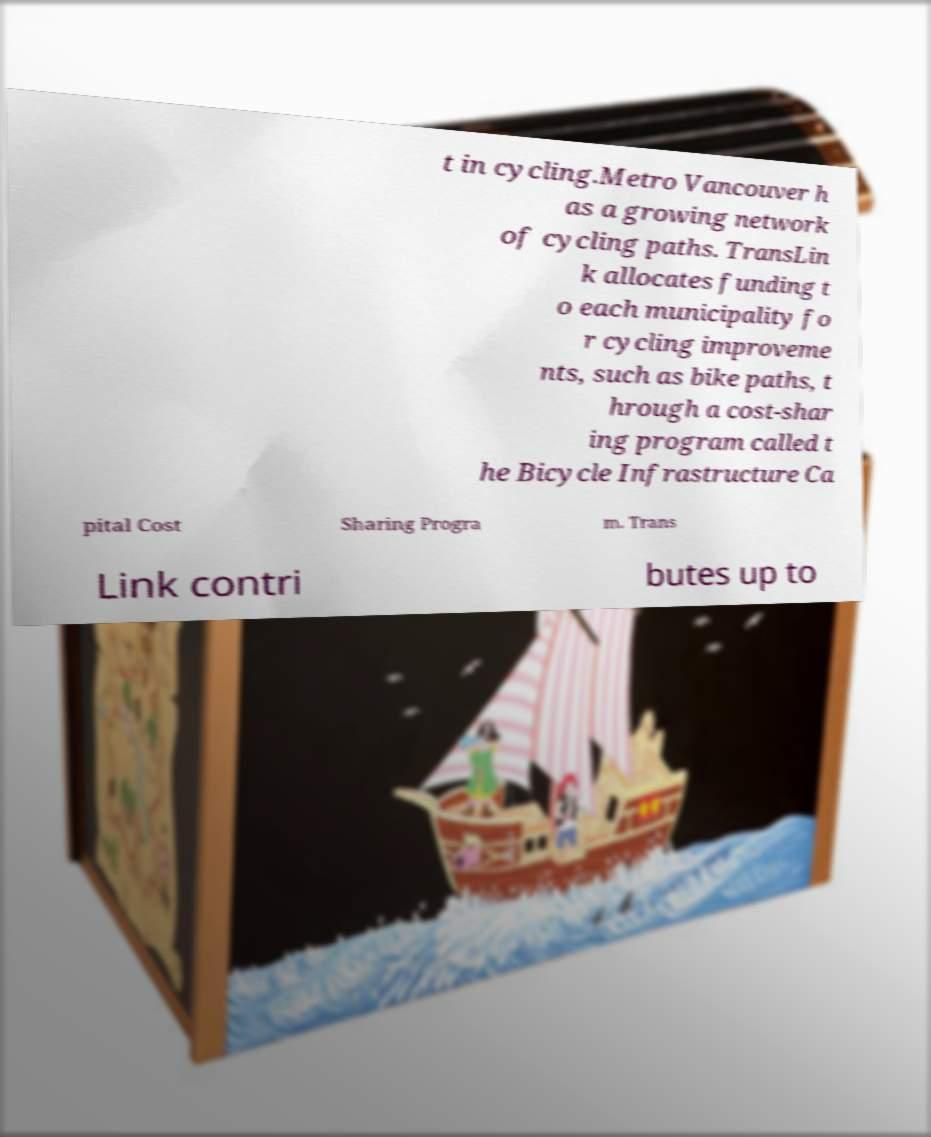Can you accurately transcribe the text from the provided image for me? t in cycling.Metro Vancouver h as a growing network of cycling paths. TransLin k allocates funding t o each municipality fo r cycling improveme nts, such as bike paths, t hrough a cost-shar ing program called t he Bicycle Infrastructure Ca pital Cost Sharing Progra m. Trans Link contri butes up to 